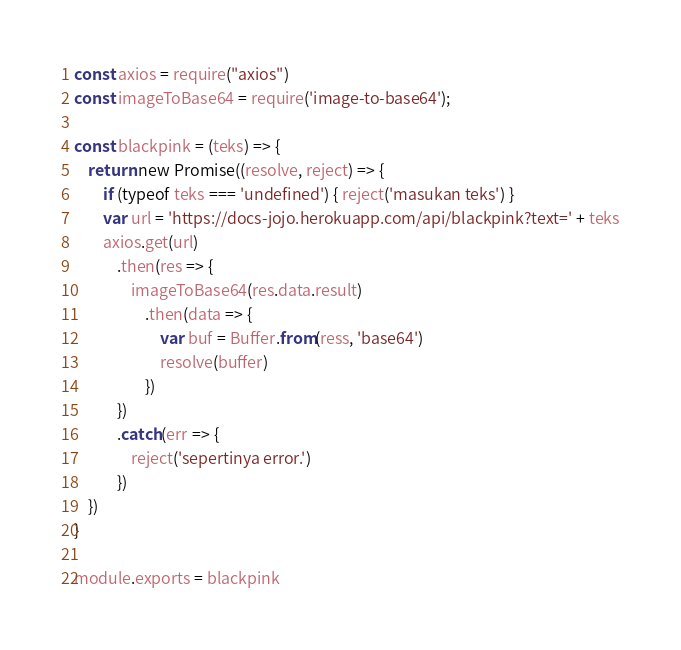<code> <loc_0><loc_0><loc_500><loc_500><_JavaScript_>const axios = require("axios")
const imageToBase64 = require('image-to-base64');

const blackpink = (teks) => {
    return new Promise((resolve, reject) => {
        if (typeof teks === 'undefined') { reject('masukan teks') }
        var url = 'https://docs-jojo.herokuapp.com/api/blackpink?text=' + teks
        axios.get(url)
            .then(res => {
                imageToBase64(res.data.result)
                    .then(data => {
                        var buf = Buffer.from(ress, 'base64')
                        resolve(buffer)
                    })
            })
            .catch(err => {
                reject('sepertinya error.')
            })
    })
}

module.exports = blackpink
</code> 